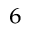<formula> <loc_0><loc_0><loc_500><loc_500>_ { 6 }</formula> 